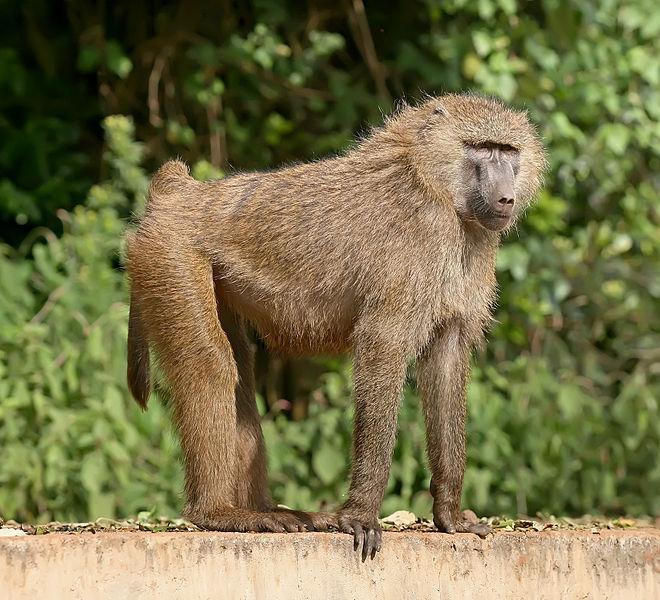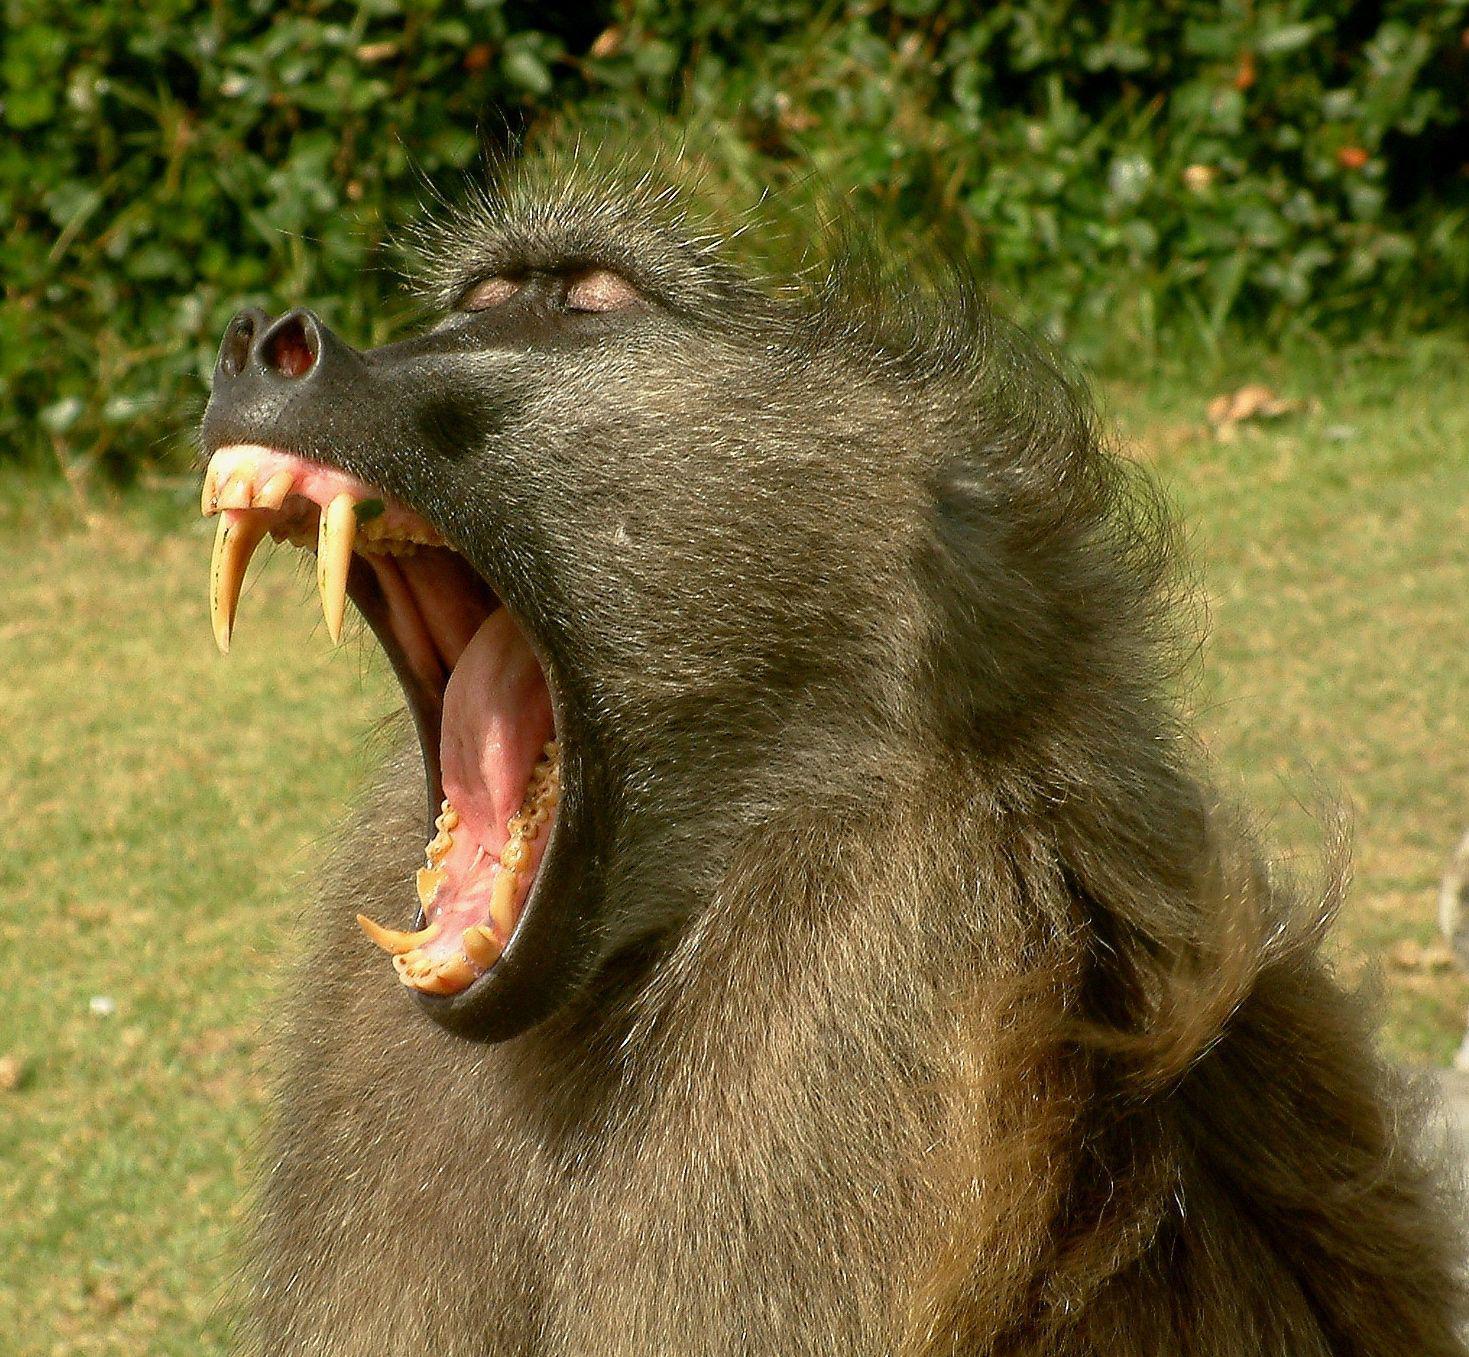The first image is the image on the left, the second image is the image on the right. Analyze the images presented: Is the assertion "There is a single animal in the image on the right baring its teeth." valid? Answer yes or no. Yes. 